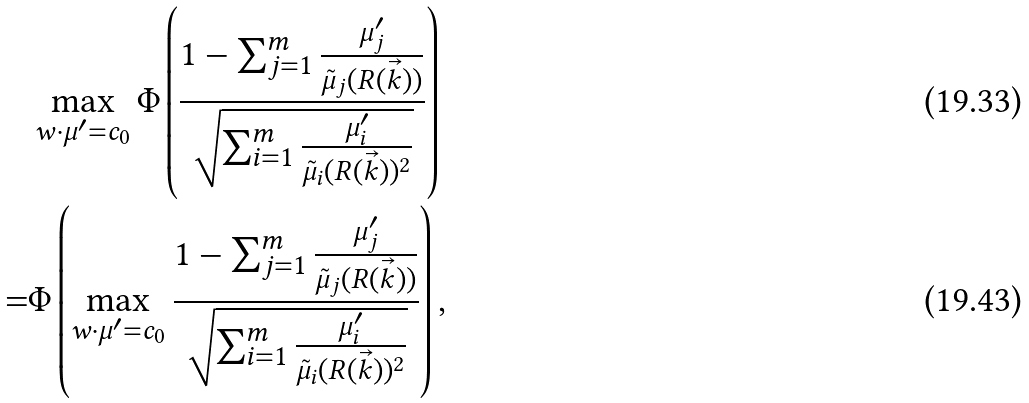<formula> <loc_0><loc_0><loc_500><loc_500>& \max _ { w \cdot \mu ^ { \prime } = c _ { 0 } } \Phi \left ( \frac { 1 - \sum _ { j = 1 } ^ { m } \frac { \mu _ { j } ^ { \prime } } { \tilde { \mu } _ { j } ( R ( \vec { k } ) ) } } { \sqrt { \sum _ { i = 1 } ^ { m } \frac { \mu _ { i } ^ { \prime } } { \tilde { \mu } _ { i } ( R ( \vec { k } ) ) ^ { 2 } } } } \right ) \\ = & \Phi \left ( \max _ { w \cdot \mu ^ { \prime } = c _ { 0 } } \frac { 1 - \sum _ { j = 1 } ^ { m } \frac { \mu _ { j } ^ { \prime } } { \tilde { \mu } _ { j } ( R ( \vec { k } ) ) } } { \sqrt { \sum _ { i = 1 } ^ { m } \frac { \mu _ { i } ^ { \prime } } { \tilde { \mu } _ { i } ( R ( \vec { k } ) ) ^ { 2 } } } } \right ) ,</formula> 